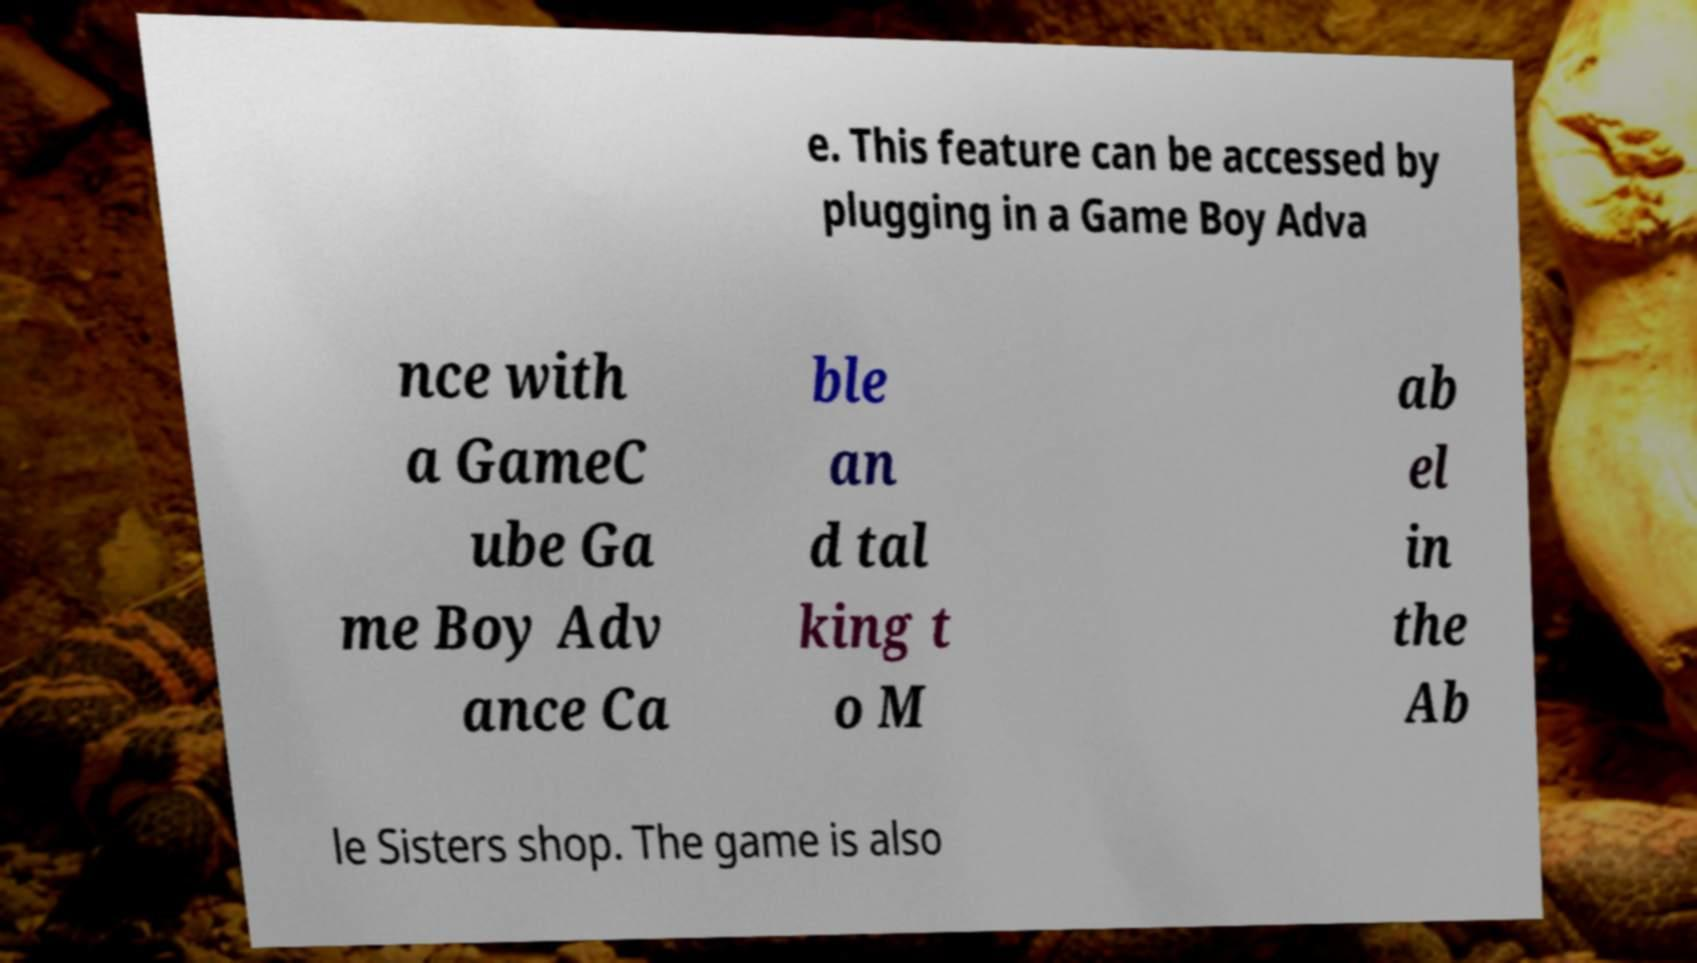Can you accurately transcribe the text from the provided image for me? e. This feature can be accessed by plugging in a Game Boy Adva nce with a GameC ube Ga me Boy Adv ance Ca ble an d tal king t o M ab el in the Ab le Sisters shop. The game is also 